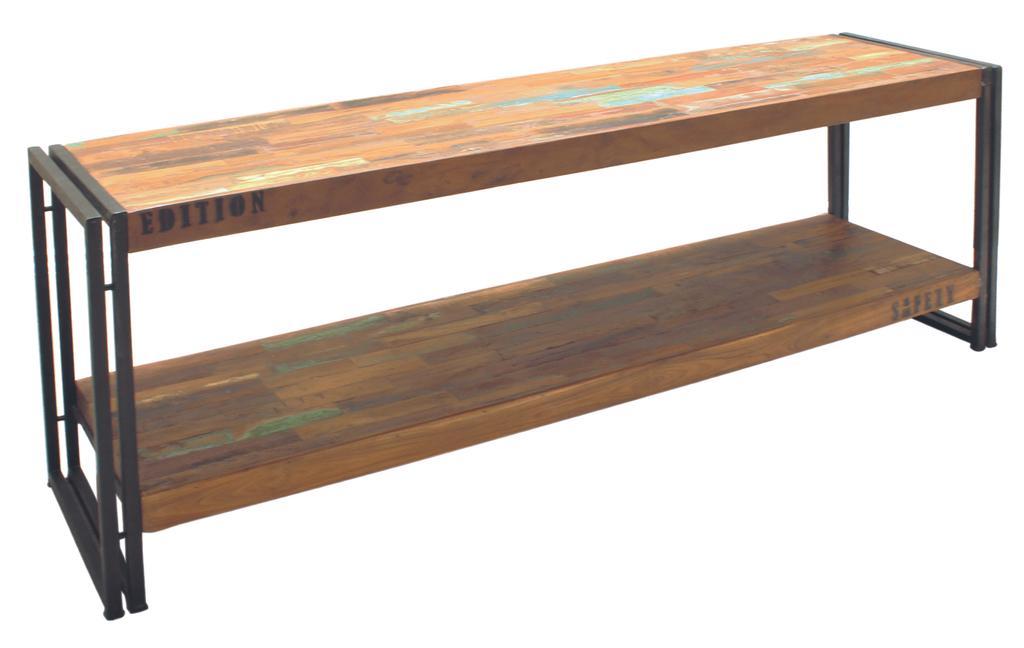What is written on the top plank?
Your answer should be compact. Edition. 